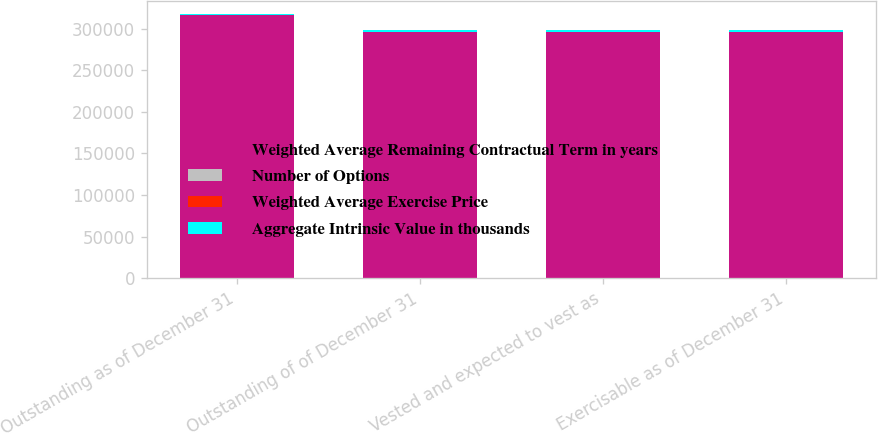Convert chart. <chart><loc_0><loc_0><loc_500><loc_500><stacked_bar_chart><ecel><fcel>Outstanding as of December 31<fcel>Outstanding of of December 31<fcel>Vested and expected to vest as<fcel>Exercisable as of December 31<nl><fcel>Weighted Average Remaining Contractual Term in years<fcel>315924<fcel>295924<fcel>295924<fcel>295924<nl><fcel>Number of Options<fcel>52.39<fcel>52.46<fcel>52.46<fcel>52.46<nl><fcel>Weighted Average Exercise Price<fcel>2.1<fcel>1.1<fcel>1.1<fcel>1.1<nl><fcel>Aggregate Intrinsic Value in thousands<fcel>1664<fcel>1822<fcel>1822<fcel>1822<nl></chart> 